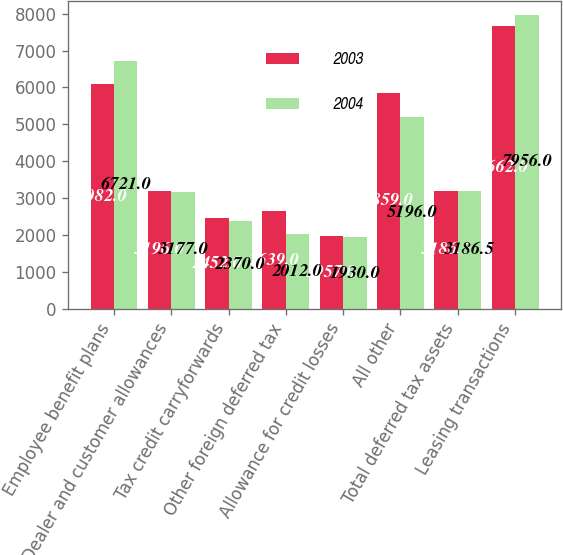<chart> <loc_0><loc_0><loc_500><loc_500><stacked_bar_chart><ecel><fcel>Employee benefit plans<fcel>Dealer and customer allowances<fcel>Tax credit carryforwards<fcel>Other foreign deferred tax<fcel>Allowance for credit losses<fcel>All other<fcel>Total deferred tax assets<fcel>Leasing transactions<nl><fcel>2003<fcel>6082<fcel>3196<fcel>2452<fcel>2639<fcel>1957<fcel>5859<fcel>3186.5<fcel>7662<nl><fcel>2004<fcel>6721<fcel>3177<fcel>2370<fcel>2012<fcel>1930<fcel>5196<fcel>3186.5<fcel>7956<nl></chart> 